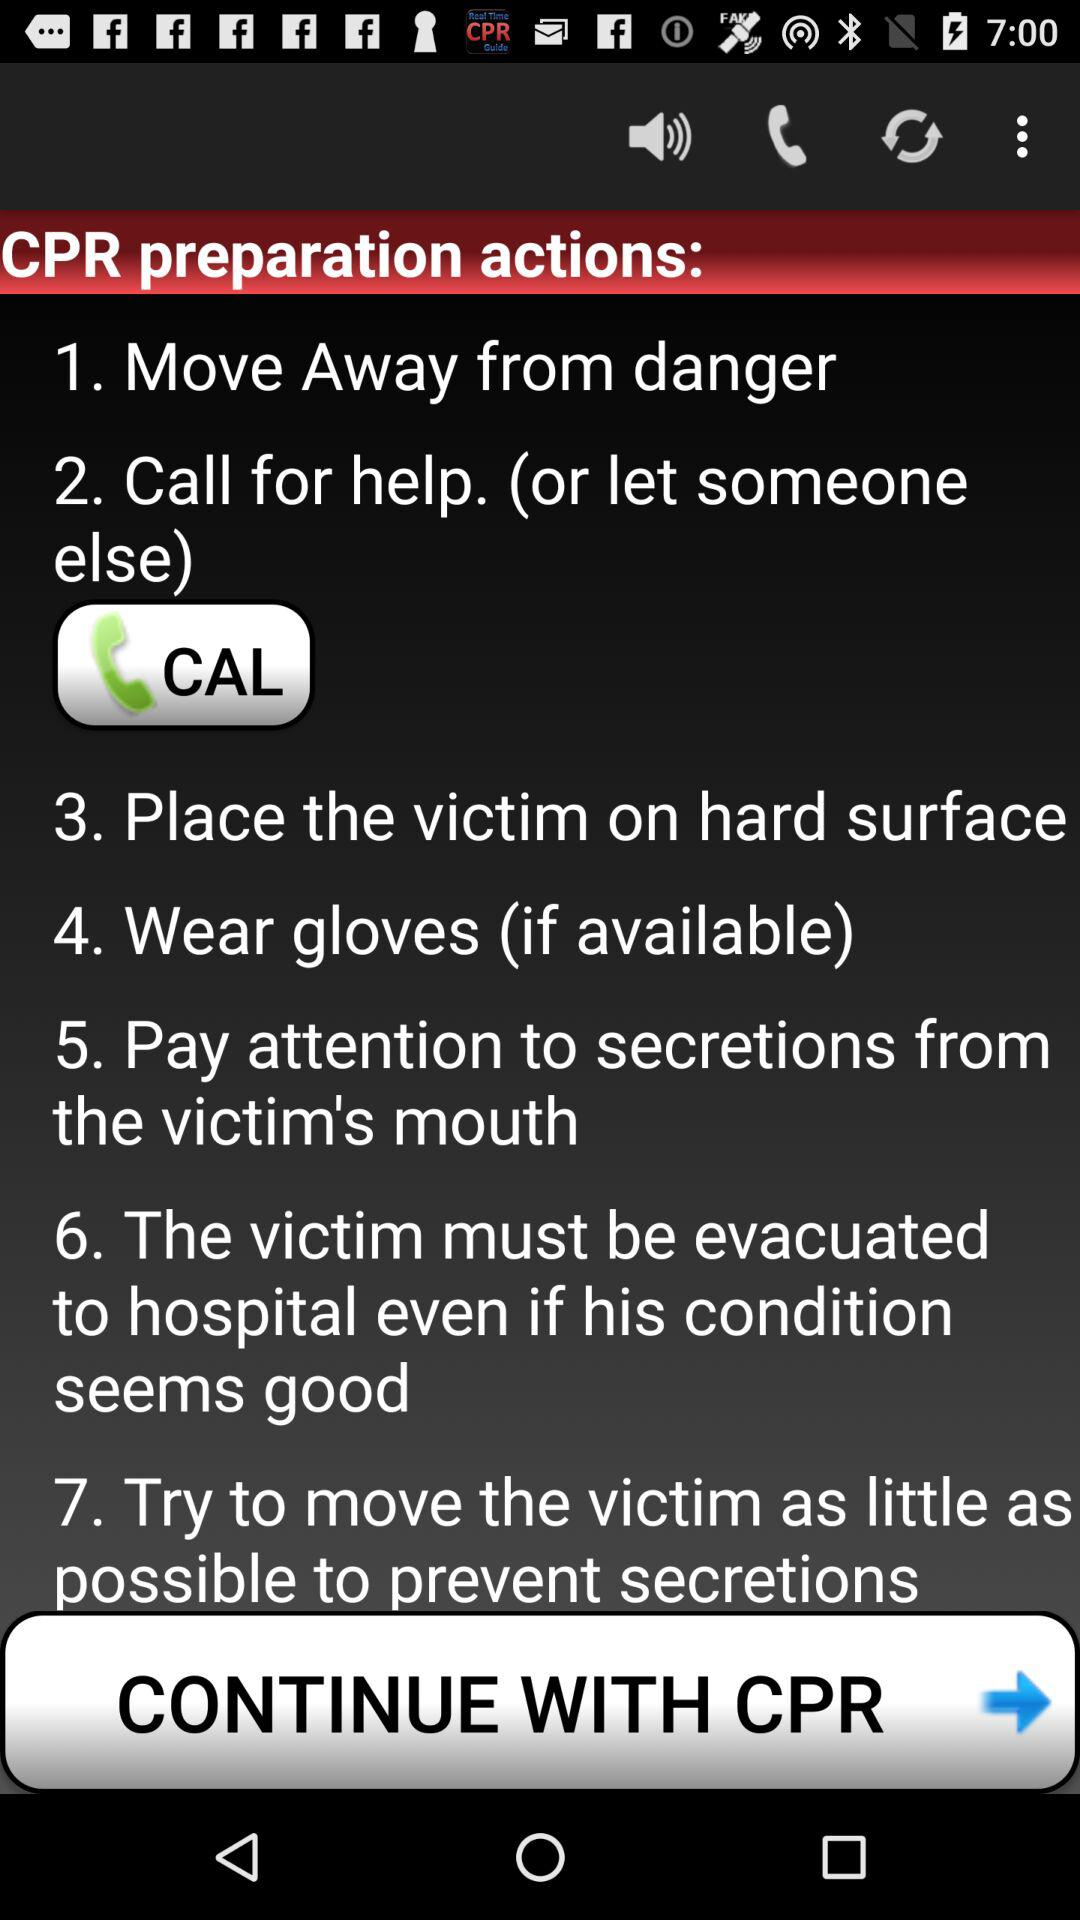How many steps are there in the CPR preparation actions?
Answer the question using a single word or phrase. 7 